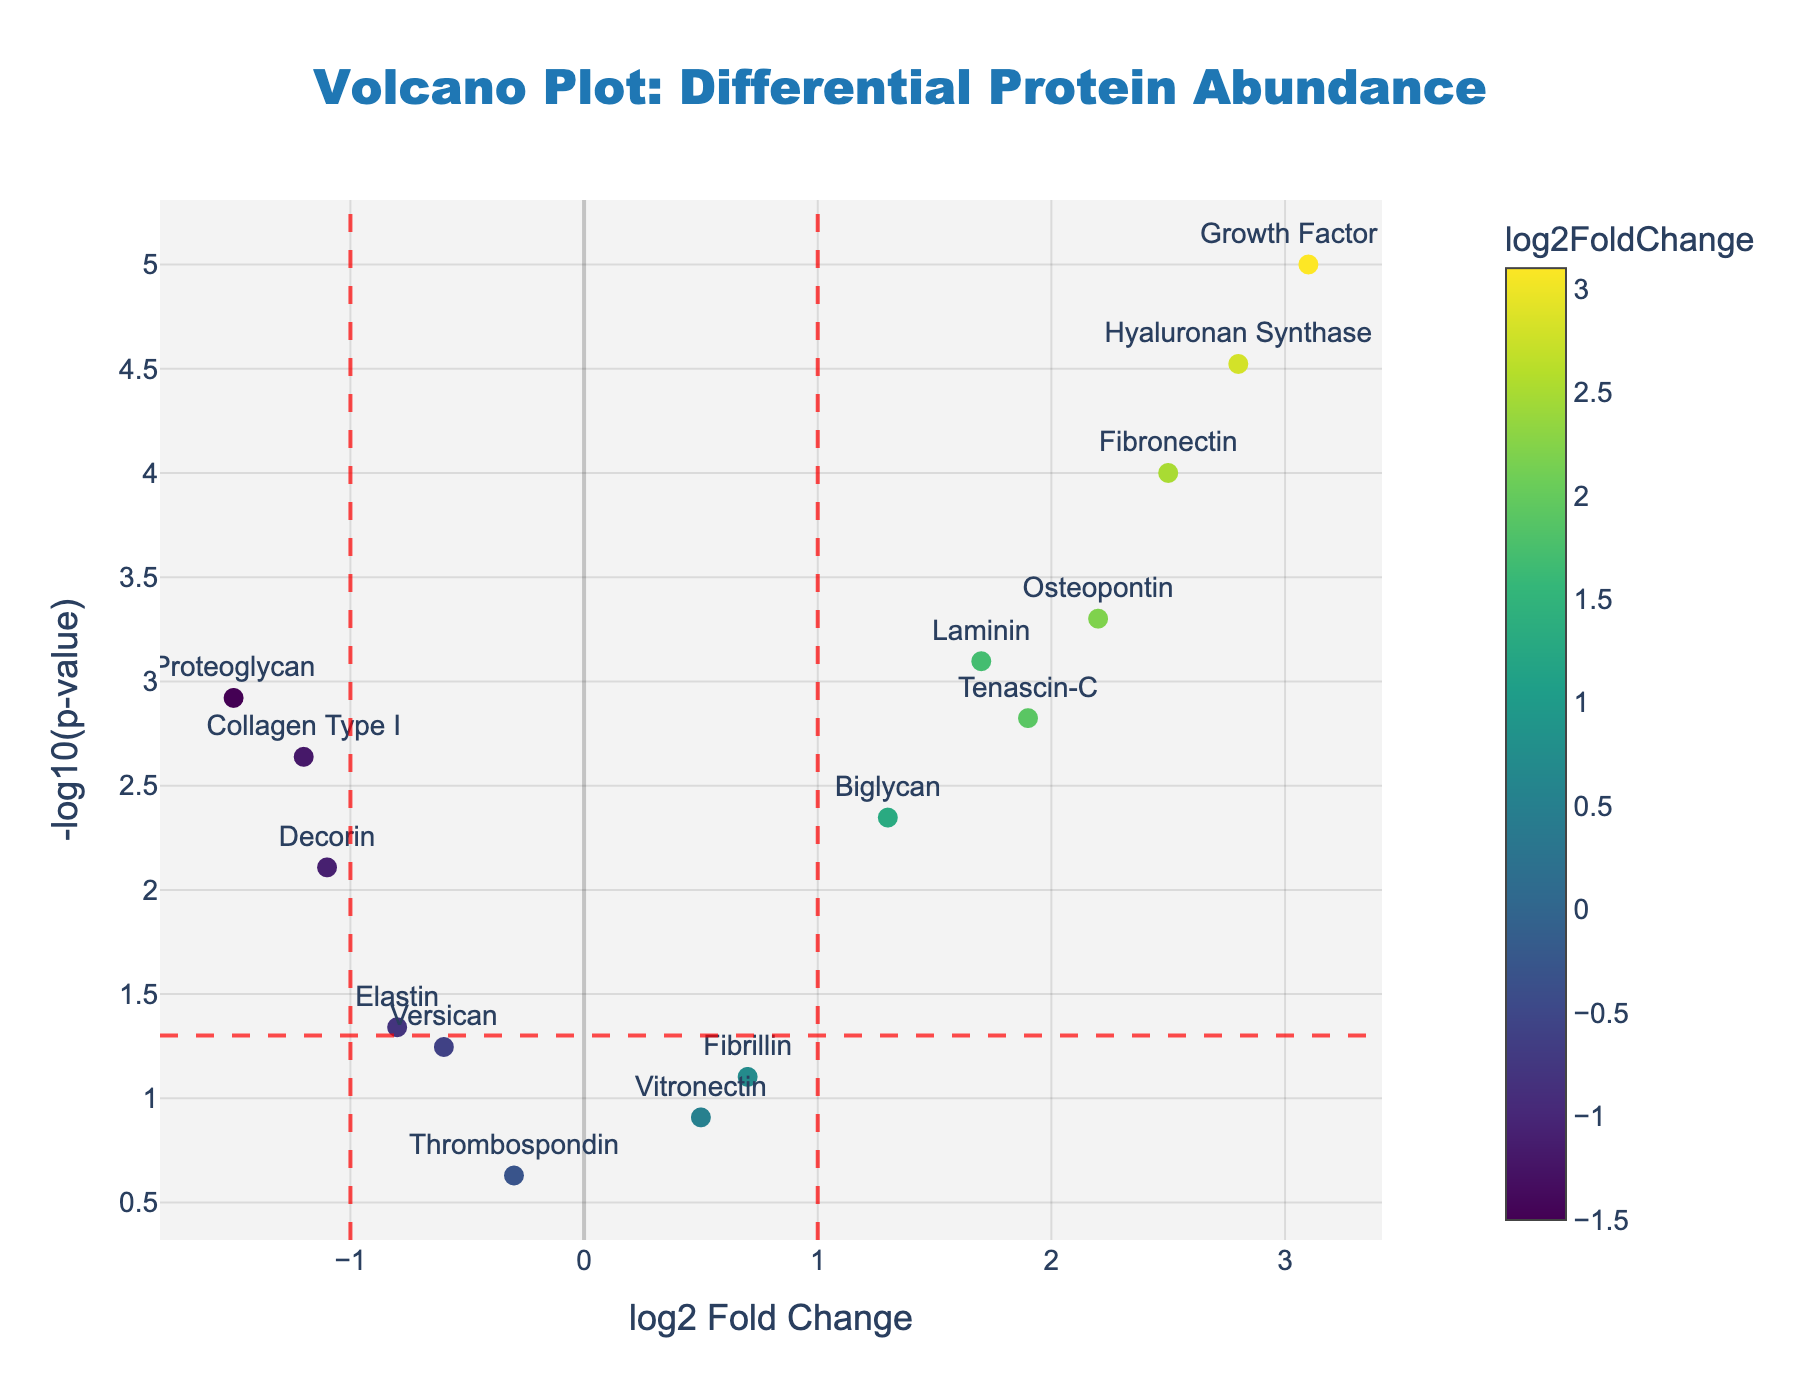What is the title of the figure? The title is located at the top of the figure. It provides a summary of what the plot represents.
Answer: Volcano Plot: Differential Protein Abundance What does the x-axis represent? The x-axis label provides information about what it represents. In this figure, it shows "log2 Fold Change," indicating how much the protein abundance has increased or decreased.
Answer: log2 Fold Change How many proteins have a log2 fold change greater than 2? To answer this, we check the x-axis values for any points (proteins) that are greater than 2.
Answer: 3 Which protein has the lowest p-value? The p-value is plotted as -log10(p-value) on the y-axis. The higher the point on the y-axis, the lower the p-value.
Answer: Growth Factor β1 Which proteins are considered significant both in terms of fold change and p-value? Proteins considered significant have a log2 fold change greater than ±1 and a p-value less than 0.05 (marked by the dashed lines).
Answer: Fibronectin, Laminin, Growth Factor β1, Osteopontin, Tenascin-C, Hyaluronan Synthase, Biglycan, Proteoglycan What is the log2 fold change and p-value of the protein Tenascin-C? Hover information reveals the specific details of each point. For Tenascin-C, we check its log2 fold change (1.9) and p-value (0.0015).
Answer: log2FC: 1.9, p-value: 0.0015 Between Fibronectin and Elastin, which protein shows a greater increase in abundance? We compare the log2 fold change values. Fibronectin shows an increase of 2.5, while Elastin shows -0.8.
Answer: Fibronectin Is there any protein with a log2 fold change close to 0 but still significant? We check the points near x=0 and within the significance threshold line on the y-axis.
Answer: Vitronectin (log2FC: 0.5, p-value: 0.1234), not highly significant What is the threshold used for the p-value to determine significance? The threshold for significance is indicated by the dashed horizontal line on the y-axis, corresponding to a p-value of 0.05
Answer: 0.05 